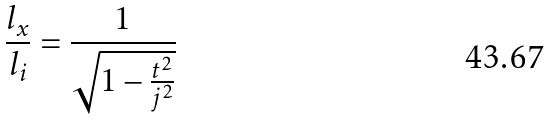<formula> <loc_0><loc_0><loc_500><loc_500>\frac { l _ { x } } { l _ { i } } = \frac { 1 } { \sqrt { 1 - \frac { t ^ { 2 } } { j ^ { 2 } } } }</formula> 